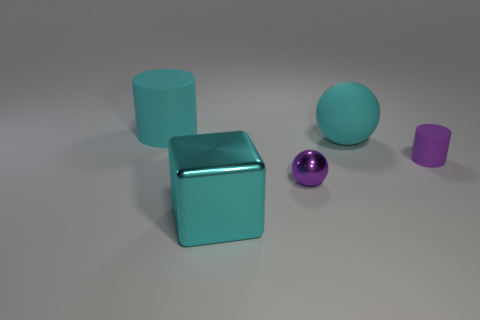How would the lighting in this room affect the appearance of these objects if it were dimmer? If the lighting were dimmer, the objects would appear less bright and their colors less vibrant. The reflective surfaces, like the shiny purple ball, would exhibit subdued highlights and the overall scene might have a more muted look. 